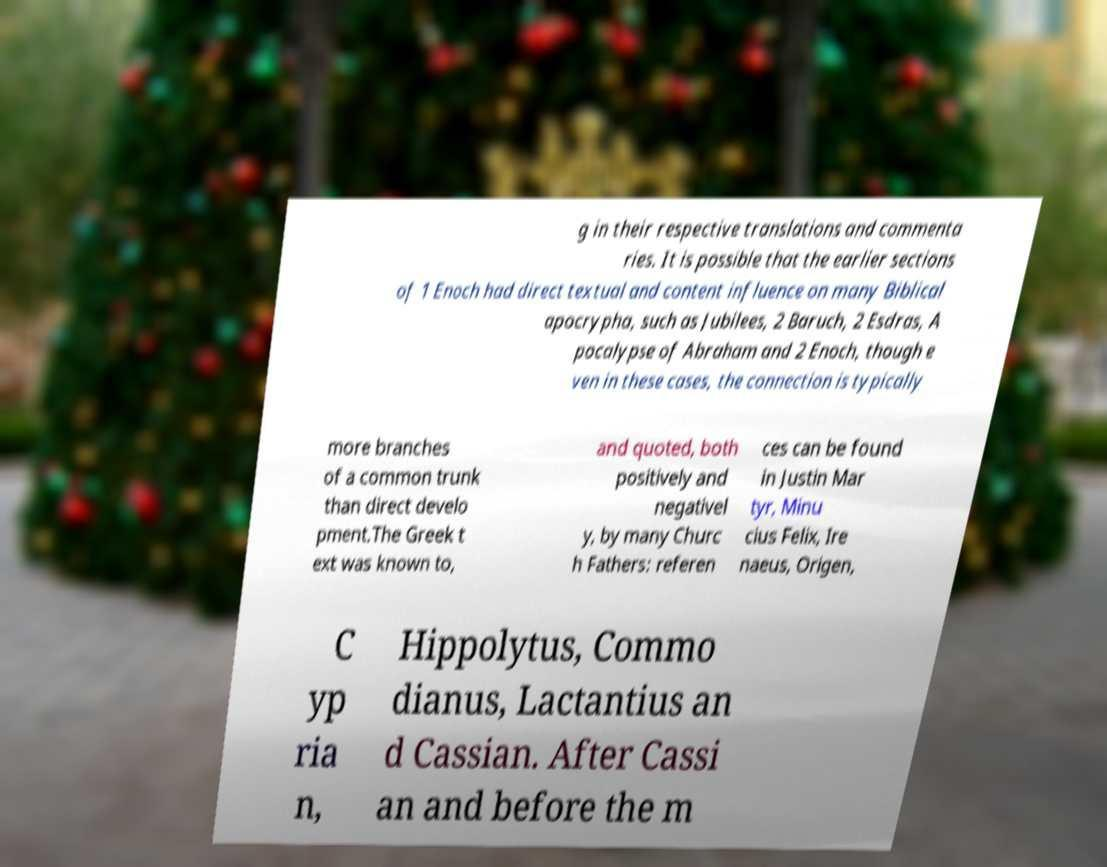Please identify and transcribe the text found in this image. g in their respective translations and commenta ries. It is possible that the earlier sections of 1 Enoch had direct textual and content influence on many Biblical apocrypha, such as Jubilees, 2 Baruch, 2 Esdras, A pocalypse of Abraham and 2 Enoch, though e ven in these cases, the connection is typically more branches of a common trunk than direct develo pment.The Greek t ext was known to, and quoted, both positively and negativel y, by many Churc h Fathers: referen ces can be found in Justin Mar tyr, Minu cius Felix, Ire naeus, Origen, C yp ria n, Hippolytus, Commo dianus, Lactantius an d Cassian. After Cassi an and before the m 